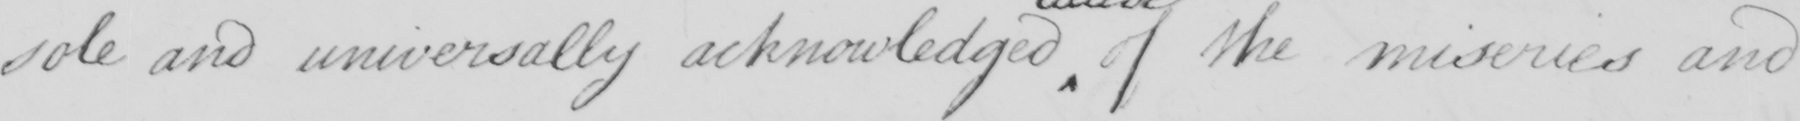Please transcribe the handwritten text in this image. sole and universally acknowledged of the miseries and 